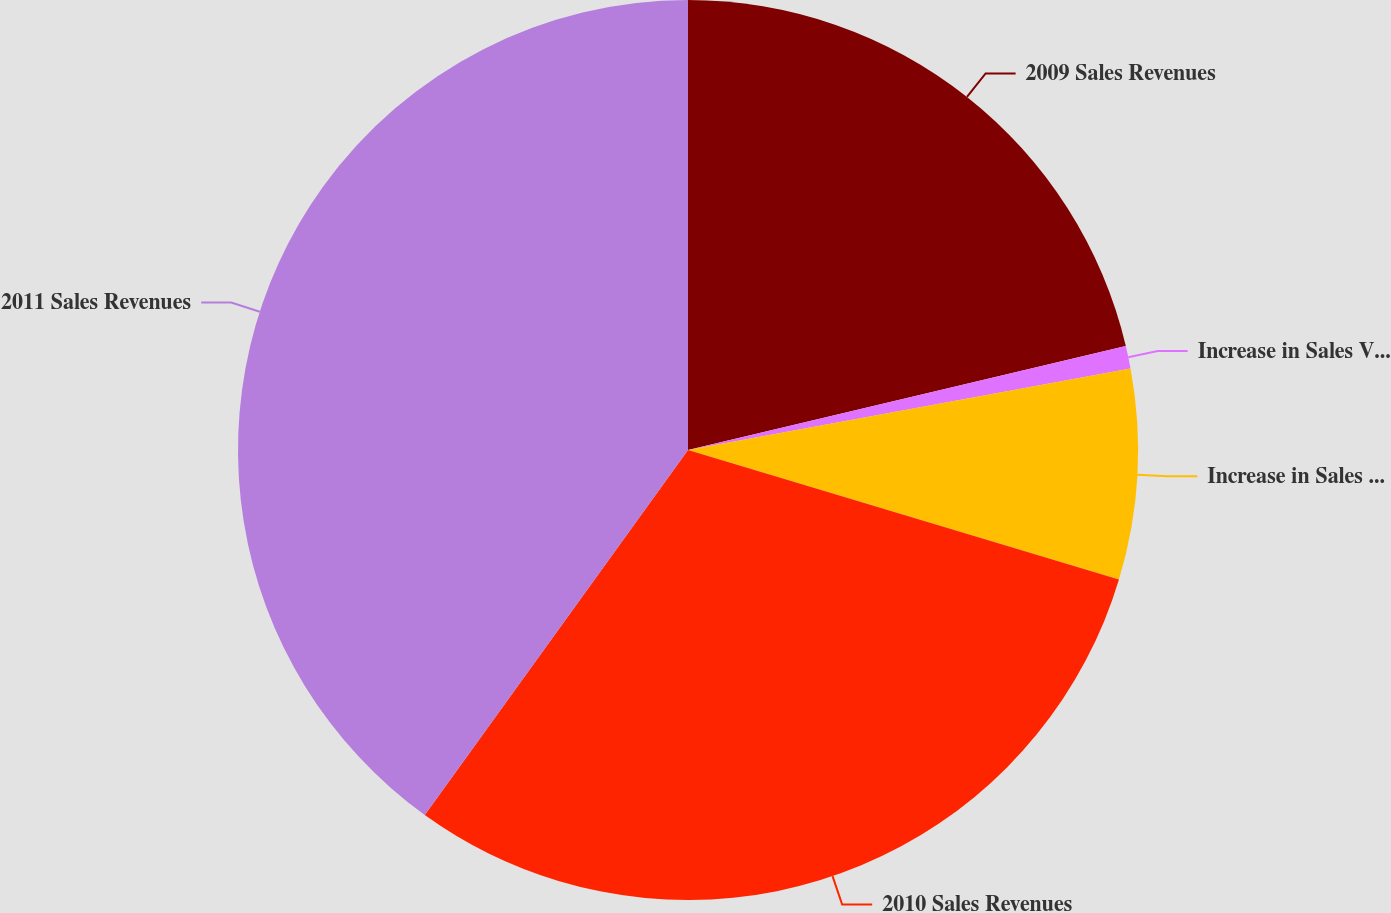Convert chart to OTSL. <chart><loc_0><loc_0><loc_500><loc_500><pie_chart><fcel>2009 Sales Revenues<fcel>Increase in Sales Volumes<fcel>Increase in Sales Prices<fcel>2010 Sales Revenues<fcel>2011 Sales Revenues<nl><fcel>21.29%<fcel>0.81%<fcel>7.55%<fcel>30.3%<fcel>40.06%<nl></chart> 